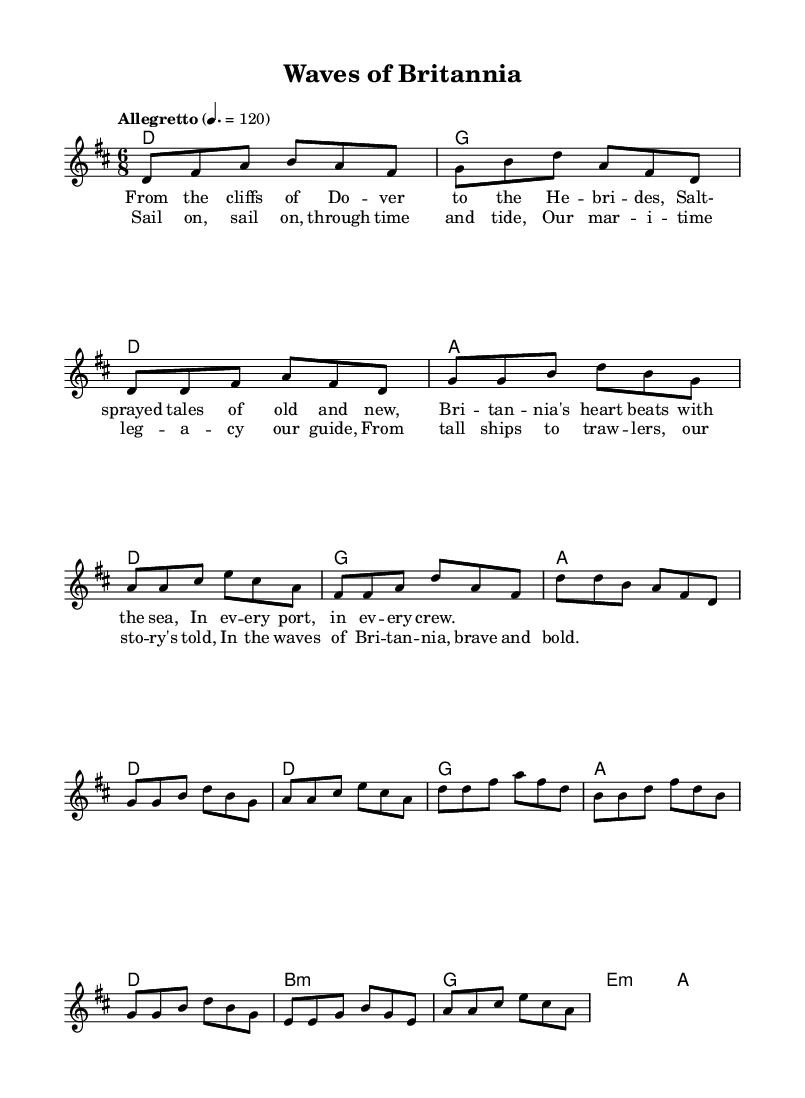What is the key signature of this music? The key signature is D major, which has two sharps (F# and C#). This can be identified at the beginning of the sheet music in the key signature section.
Answer: D major What is the time signature of this piece? The time signature is 6/8, which indicates there are six eighth notes in each measure. This is visible next to the key signature at the beginning of the score.
Answer: 6/8 What is the tempo marking of this piece? The tempo marking is "Allegretto" with a metronome indication of 120. This is noted in the tempo section of the music, indicating the speed at which the music should be played.
Answer: Allegretto 120 How many measures are in the chorus? The chorus consists of four measures, which can be seen by counting the measures in the chorus section marked in the sheet music.
Answer: 4 What is the primary theme of the lyrics? The primary theme of the lyrics reflects maritime heritage, celebrating seafaring traditions and the stories of the sea. This is evident in terms and phrases used throughout the lyrics.
Answer: Maritime heritage How is the bridge different from the verse in musical terms? The bridge introduces new chords and a variation in melody that creates contrast with the verse. This can be seen by examining the chord progression and melody line in the sheet music, showing different pitches and harmonies.
Answer: New chords What type of instrumentation is likely used in this folk-rock piece? The instrumentation likely includes traditional folk instruments such as acoustic guitar and perhaps a fiddle, as these are common in folk-rock arrangements. This deduction comes from the folk style and lyrical themes associated with maritime heritage.
Answer: Acoustic guitar 